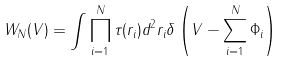Convert formula to latex. <formula><loc_0><loc_0><loc_500><loc_500>W _ { N } ( { V } ) = \int \prod _ { i = 1 } ^ { N } \tau ( { r } _ { i } ) d ^ { 2 } { r } _ { i } \delta \left ( { V } - \sum _ { i = 1 } ^ { N } { \Phi } _ { i } \right )</formula> 